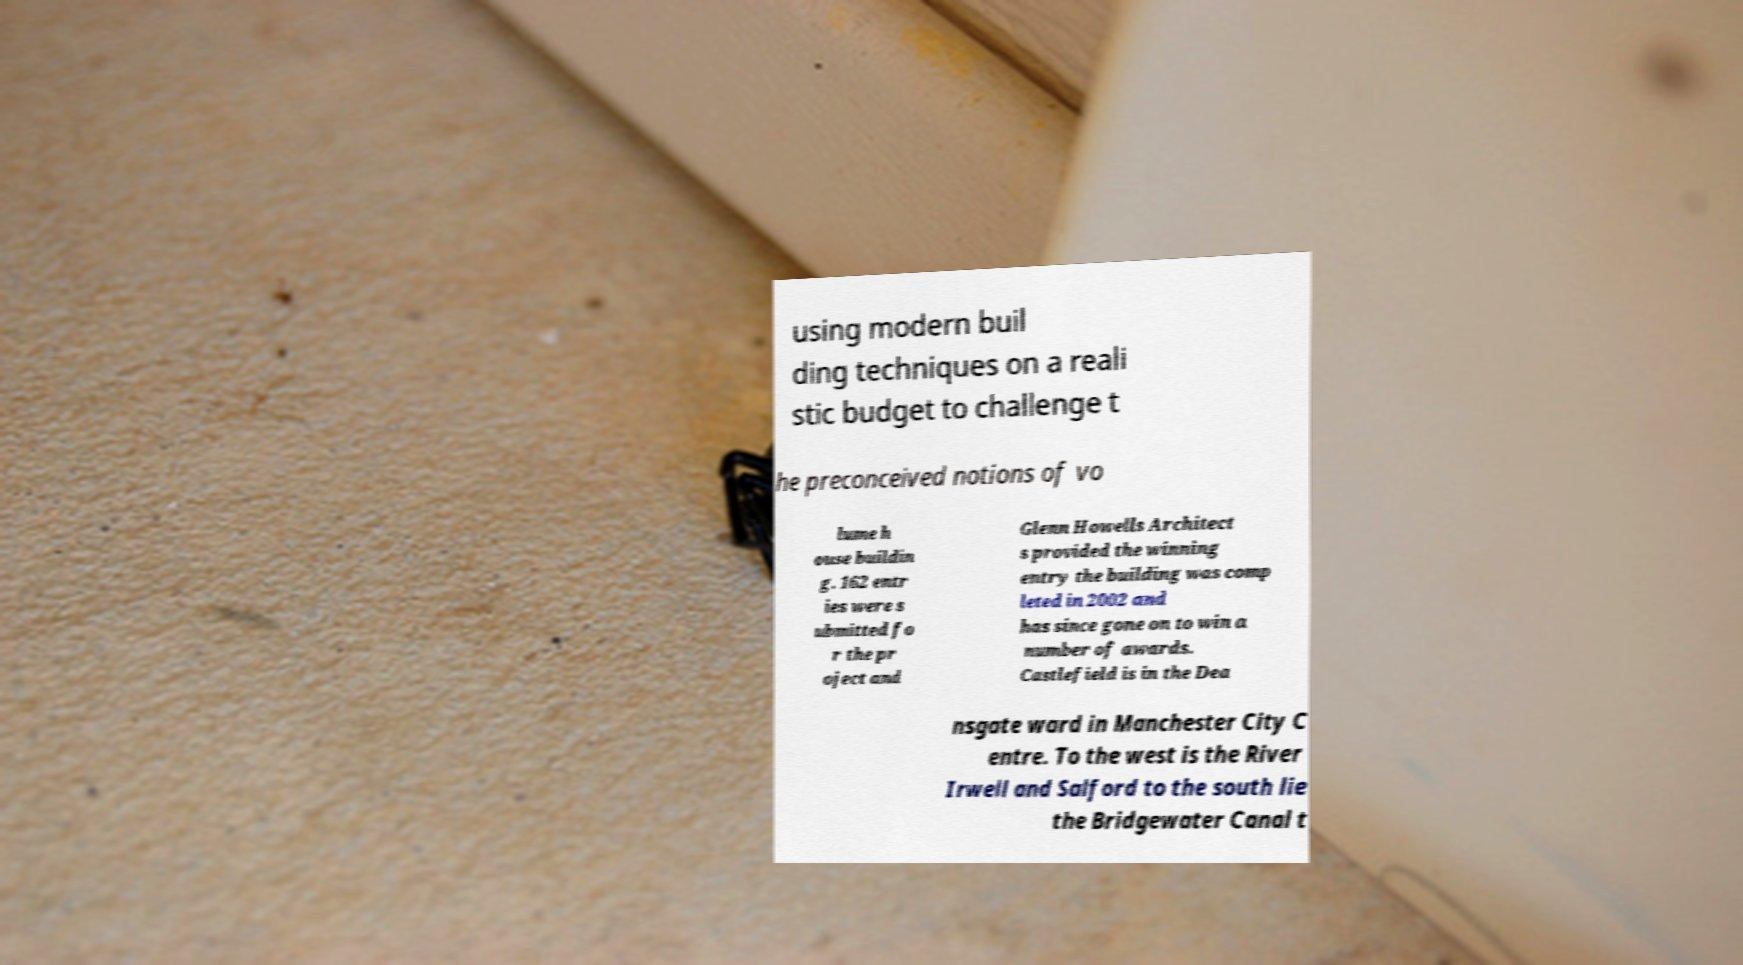Could you extract and type out the text from this image? using modern buil ding techniques on a reali stic budget to challenge t he preconceived notions of vo lume h ouse buildin g. 162 entr ies were s ubmitted fo r the pr oject and Glenn Howells Architect s provided the winning entry the building was comp leted in 2002 and has since gone on to win a number of awards. Castlefield is in the Dea nsgate ward in Manchester City C entre. To the west is the River Irwell and Salford to the south lie the Bridgewater Canal t 